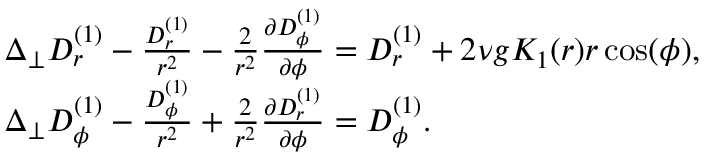Convert formula to latex. <formula><loc_0><loc_0><loc_500><loc_500>\begin{array} { r l } & { \Delta _ { \perp } D _ { r } ^ { ( 1 ) } - \frac { D _ { r } ^ { ( 1 ) } } { r ^ { 2 } } - \frac { 2 } { r ^ { 2 } } \frac { \partial D _ { \phi } ^ { ( 1 ) } } { \partial \phi } = D _ { r } ^ { ( 1 ) } + 2 \nu g K _ { 1 } ( r ) r \cos ( \phi ) , } \\ & { \Delta _ { \perp } D _ { \phi } ^ { ( 1 ) } - \frac { D _ { \phi } ^ { ( 1 ) } } { r ^ { 2 } } + \frac { 2 } { r ^ { 2 } } \frac { \partial D _ { r } ^ { ( 1 ) } } { \partial \phi } = D _ { \phi } ^ { ( 1 ) } . } \end{array}</formula> 